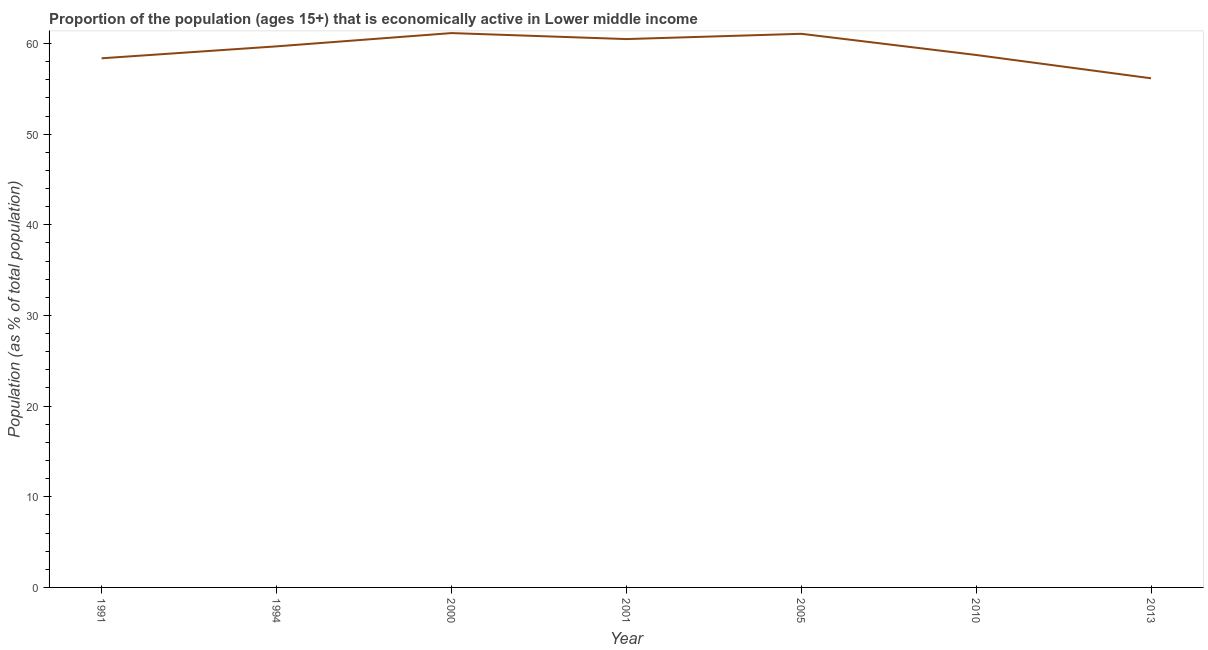What is the percentage of economically active population in 2000?
Provide a short and direct response. 61.15. Across all years, what is the maximum percentage of economically active population?
Offer a terse response. 61.15. Across all years, what is the minimum percentage of economically active population?
Make the answer very short. 56.17. In which year was the percentage of economically active population minimum?
Give a very brief answer. 2013. What is the sum of the percentage of economically active population?
Your answer should be very brief. 415.68. What is the difference between the percentage of economically active population in 1991 and 2001?
Keep it short and to the point. -2.12. What is the average percentage of economically active population per year?
Offer a terse response. 59.38. What is the median percentage of economically active population?
Ensure brevity in your answer.  59.69. In how many years, is the percentage of economically active population greater than 16 %?
Keep it short and to the point. 7. What is the ratio of the percentage of economically active population in 2001 to that in 2010?
Keep it short and to the point. 1.03. Is the percentage of economically active population in 1994 less than that in 2000?
Your response must be concise. Yes. What is the difference between the highest and the second highest percentage of economically active population?
Your response must be concise. 0.08. Is the sum of the percentage of economically active population in 2001 and 2013 greater than the maximum percentage of economically active population across all years?
Ensure brevity in your answer.  Yes. What is the difference between the highest and the lowest percentage of economically active population?
Your response must be concise. 4.99. In how many years, is the percentage of economically active population greater than the average percentage of economically active population taken over all years?
Your answer should be very brief. 4. Does the percentage of economically active population monotonically increase over the years?
Provide a short and direct response. No. What is the difference between two consecutive major ticks on the Y-axis?
Your answer should be very brief. 10. Does the graph contain any zero values?
Provide a succinct answer. No. Does the graph contain grids?
Provide a short and direct response. No. What is the title of the graph?
Provide a succinct answer. Proportion of the population (ages 15+) that is economically active in Lower middle income. What is the label or title of the X-axis?
Provide a succinct answer. Year. What is the label or title of the Y-axis?
Your answer should be very brief. Population (as % of total population). What is the Population (as % of total population) in 1991?
Your answer should be very brief. 58.37. What is the Population (as % of total population) in 1994?
Your answer should be compact. 59.69. What is the Population (as % of total population) in 2000?
Make the answer very short. 61.15. What is the Population (as % of total population) in 2001?
Offer a terse response. 60.49. What is the Population (as % of total population) of 2005?
Provide a short and direct response. 61.07. What is the Population (as % of total population) of 2010?
Make the answer very short. 58.74. What is the Population (as % of total population) in 2013?
Provide a succinct answer. 56.17. What is the difference between the Population (as % of total population) in 1991 and 1994?
Your response must be concise. -1.32. What is the difference between the Population (as % of total population) in 1991 and 2000?
Your answer should be compact. -2.78. What is the difference between the Population (as % of total population) in 1991 and 2001?
Provide a short and direct response. -2.12. What is the difference between the Population (as % of total population) in 1991 and 2005?
Keep it short and to the point. -2.7. What is the difference between the Population (as % of total population) in 1991 and 2010?
Ensure brevity in your answer.  -0.36. What is the difference between the Population (as % of total population) in 1991 and 2013?
Your answer should be very brief. 2.21. What is the difference between the Population (as % of total population) in 1994 and 2000?
Ensure brevity in your answer.  -1.46. What is the difference between the Population (as % of total population) in 1994 and 2001?
Make the answer very short. -0.8. What is the difference between the Population (as % of total population) in 1994 and 2005?
Your answer should be very brief. -1.39. What is the difference between the Population (as % of total population) in 1994 and 2010?
Provide a succinct answer. 0.95. What is the difference between the Population (as % of total population) in 1994 and 2013?
Keep it short and to the point. 3.52. What is the difference between the Population (as % of total population) in 2000 and 2001?
Your answer should be very brief. 0.66. What is the difference between the Population (as % of total population) in 2000 and 2005?
Your response must be concise. 0.08. What is the difference between the Population (as % of total population) in 2000 and 2010?
Give a very brief answer. 2.42. What is the difference between the Population (as % of total population) in 2000 and 2013?
Your response must be concise. 4.99. What is the difference between the Population (as % of total population) in 2001 and 2005?
Make the answer very short. -0.58. What is the difference between the Population (as % of total population) in 2001 and 2010?
Your answer should be compact. 1.75. What is the difference between the Population (as % of total population) in 2001 and 2013?
Give a very brief answer. 4.33. What is the difference between the Population (as % of total population) in 2005 and 2010?
Give a very brief answer. 2.34. What is the difference between the Population (as % of total population) in 2005 and 2013?
Provide a short and direct response. 4.91. What is the difference between the Population (as % of total population) in 2010 and 2013?
Keep it short and to the point. 2.57. What is the ratio of the Population (as % of total population) in 1991 to that in 1994?
Your answer should be compact. 0.98. What is the ratio of the Population (as % of total population) in 1991 to that in 2000?
Offer a very short reply. 0.95. What is the ratio of the Population (as % of total population) in 1991 to that in 2005?
Your response must be concise. 0.96. What is the ratio of the Population (as % of total population) in 1991 to that in 2010?
Your answer should be very brief. 0.99. What is the ratio of the Population (as % of total population) in 1991 to that in 2013?
Provide a short and direct response. 1.04. What is the ratio of the Population (as % of total population) in 1994 to that in 2000?
Provide a short and direct response. 0.98. What is the ratio of the Population (as % of total population) in 1994 to that in 2001?
Make the answer very short. 0.99. What is the ratio of the Population (as % of total population) in 1994 to that in 2005?
Your response must be concise. 0.98. What is the ratio of the Population (as % of total population) in 1994 to that in 2013?
Your answer should be compact. 1.06. What is the ratio of the Population (as % of total population) in 2000 to that in 2001?
Offer a very short reply. 1.01. What is the ratio of the Population (as % of total population) in 2000 to that in 2005?
Keep it short and to the point. 1. What is the ratio of the Population (as % of total population) in 2000 to that in 2010?
Provide a succinct answer. 1.04. What is the ratio of the Population (as % of total population) in 2000 to that in 2013?
Ensure brevity in your answer.  1.09. What is the ratio of the Population (as % of total population) in 2001 to that in 2005?
Keep it short and to the point. 0.99. What is the ratio of the Population (as % of total population) in 2001 to that in 2013?
Ensure brevity in your answer.  1.08. What is the ratio of the Population (as % of total population) in 2005 to that in 2013?
Your response must be concise. 1.09. What is the ratio of the Population (as % of total population) in 2010 to that in 2013?
Your response must be concise. 1.05. 